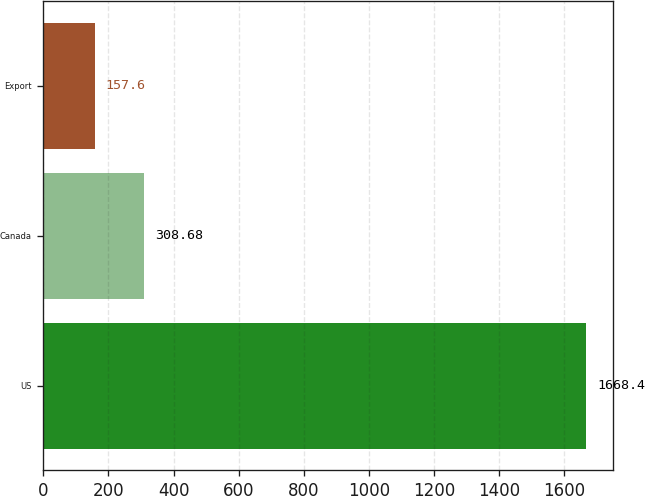Convert chart. <chart><loc_0><loc_0><loc_500><loc_500><bar_chart><fcel>US<fcel>Canada<fcel>Export<nl><fcel>1668.4<fcel>308.68<fcel>157.6<nl></chart> 